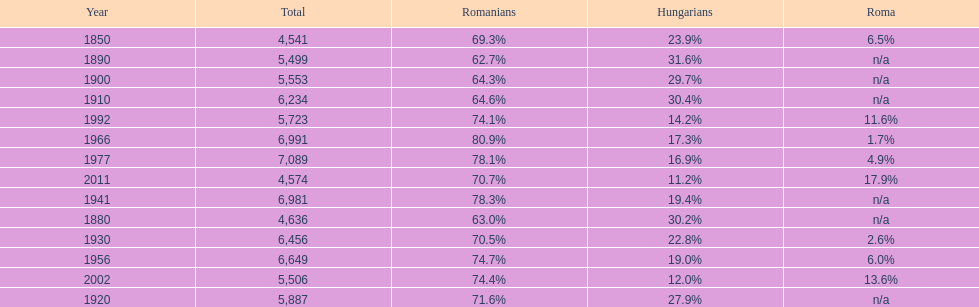What year had the next highest percentage for roma after 2011? 2002. 